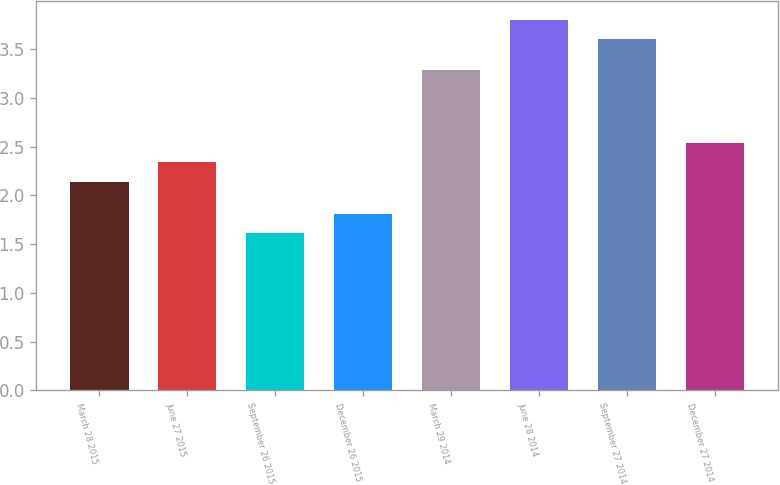Convert chart. <chart><loc_0><loc_0><loc_500><loc_500><bar_chart><fcel>March 28 2015<fcel>June 27 2015<fcel>September 26 2015<fcel>December 26 2015<fcel>March 29 2014<fcel>June 28 2014<fcel>September 27 2014<fcel>December 27 2014<nl><fcel>2.14<fcel>2.34<fcel>1.61<fcel>1.81<fcel>3.29<fcel>3.8<fcel>3.6<fcel>2.54<nl></chart> 